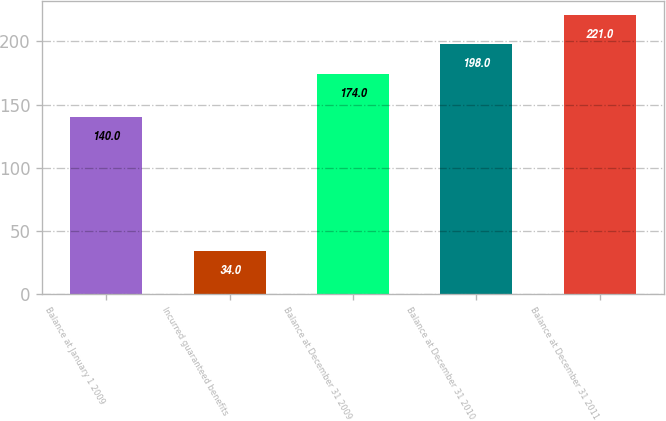Convert chart to OTSL. <chart><loc_0><loc_0><loc_500><loc_500><bar_chart><fcel>Balance at January 1 2009<fcel>Incurred guaranteed benefits<fcel>Balance at December 31 2009<fcel>Balance at December 31 2010<fcel>Balance at December 31 2011<nl><fcel>140<fcel>34<fcel>174<fcel>198<fcel>221<nl></chart> 